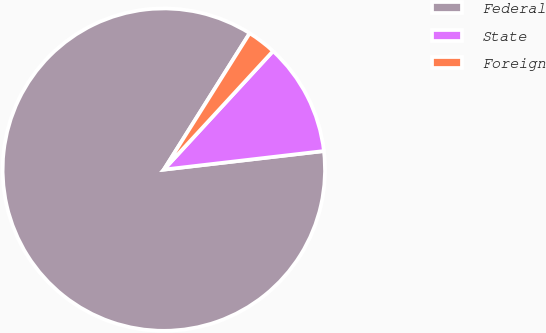<chart> <loc_0><loc_0><loc_500><loc_500><pie_chart><fcel>Federal<fcel>State<fcel>Foreign<nl><fcel>85.78%<fcel>11.31%<fcel>2.91%<nl></chart> 